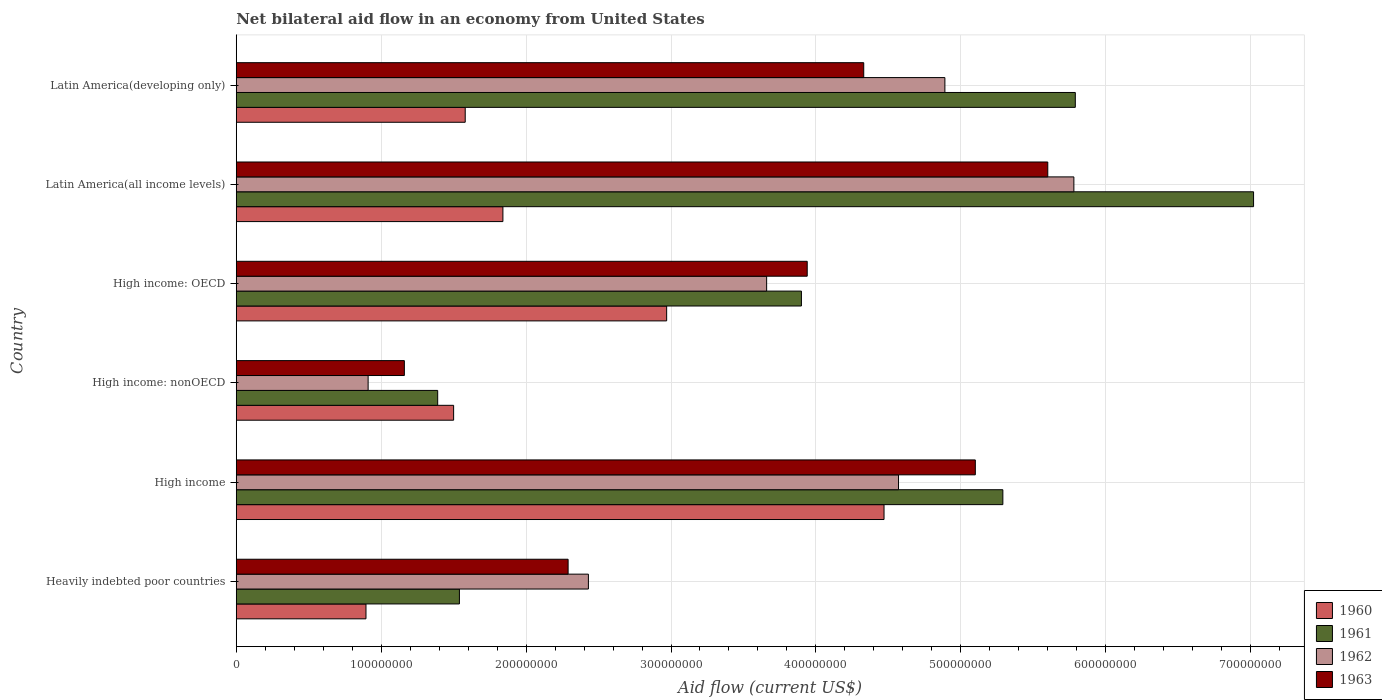How many different coloured bars are there?
Your response must be concise. 4. How many groups of bars are there?
Offer a very short reply. 6. What is the label of the 4th group of bars from the top?
Offer a terse response. High income: nonOECD. In how many cases, is the number of bars for a given country not equal to the number of legend labels?
Ensure brevity in your answer.  0. What is the net bilateral aid flow in 1960 in High income: OECD?
Your answer should be compact. 2.97e+08. Across all countries, what is the maximum net bilateral aid flow in 1962?
Make the answer very short. 5.78e+08. Across all countries, what is the minimum net bilateral aid flow in 1963?
Your response must be concise. 1.16e+08. In which country was the net bilateral aid flow in 1963 maximum?
Provide a succinct answer. Latin America(all income levels). In which country was the net bilateral aid flow in 1961 minimum?
Give a very brief answer. High income: nonOECD. What is the total net bilateral aid flow in 1963 in the graph?
Make the answer very short. 2.24e+09. What is the difference between the net bilateral aid flow in 1962 in Latin America(all income levels) and that in Latin America(developing only)?
Provide a short and direct response. 8.90e+07. What is the difference between the net bilateral aid flow in 1962 in High income and the net bilateral aid flow in 1961 in Latin America(developing only)?
Your answer should be compact. -1.22e+08. What is the average net bilateral aid flow in 1962 per country?
Ensure brevity in your answer.  3.71e+08. What is the difference between the net bilateral aid flow in 1963 and net bilateral aid flow in 1962 in High income: nonOECD?
Give a very brief answer. 2.50e+07. What is the ratio of the net bilateral aid flow in 1960 in Heavily indebted poor countries to that in Latin America(all income levels)?
Ensure brevity in your answer.  0.49. What is the difference between the highest and the second highest net bilateral aid flow in 1963?
Your answer should be compact. 5.00e+07. What is the difference between the highest and the lowest net bilateral aid flow in 1963?
Provide a short and direct response. 4.44e+08. In how many countries, is the net bilateral aid flow in 1961 greater than the average net bilateral aid flow in 1961 taken over all countries?
Your answer should be compact. 3. Is the sum of the net bilateral aid flow in 1961 in Heavily indebted poor countries and High income: OECD greater than the maximum net bilateral aid flow in 1962 across all countries?
Make the answer very short. No. Is it the case that in every country, the sum of the net bilateral aid flow in 1960 and net bilateral aid flow in 1963 is greater than the sum of net bilateral aid flow in 1962 and net bilateral aid flow in 1961?
Your answer should be compact. No. How many bars are there?
Keep it short and to the point. 24. Does the graph contain any zero values?
Your answer should be compact. No. How many legend labels are there?
Your answer should be compact. 4. How are the legend labels stacked?
Make the answer very short. Vertical. What is the title of the graph?
Offer a terse response. Net bilateral aid flow in an economy from United States. What is the label or title of the Y-axis?
Offer a very short reply. Country. What is the Aid flow (current US$) of 1960 in Heavily indebted poor countries?
Make the answer very short. 8.95e+07. What is the Aid flow (current US$) of 1961 in Heavily indebted poor countries?
Make the answer very short. 1.54e+08. What is the Aid flow (current US$) in 1962 in Heavily indebted poor countries?
Offer a terse response. 2.43e+08. What is the Aid flow (current US$) in 1963 in Heavily indebted poor countries?
Your answer should be very brief. 2.29e+08. What is the Aid flow (current US$) of 1960 in High income?
Your answer should be compact. 4.47e+08. What is the Aid flow (current US$) of 1961 in High income?
Your answer should be compact. 5.29e+08. What is the Aid flow (current US$) in 1962 in High income?
Ensure brevity in your answer.  4.57e+08. What is the Aid flow (current US$) of 1963 in High income?
Your response must be concise. 5.10e+08. What is the Aid flow (current US$) of 1960 in High income: nonOECD?
Give a very brief answer. 1.50e+08. What is the Aid flow (current US$) in 1961 in High income: nonOECD?
Your answer should be compact. 1.39e+08. What is the Aid flow (current US$) of 1962 in High income: nonOECD?
Give a very brief answer. 9.10e+07. What is the Aid flow (current US$) of 1963 in High income: nonOECD?
Offer a very short reply. 1.16e+08. What is the Aid flow (current US$) of 1960 in High income: OECD?
Ensure brevity in your answer.  2.97e+08. What is the Aid flow (current US$) of 1961 in High income: OECD?
Ensure brevity in your answer.  3.90e+08. What is the Aid flow (current US$) of 1962 in High income: OECD?
Offer a terse response. 3.66e+08. What is the Aid flow (current US$) in 1963 in High income: OECD?
Make the answer very short. 3.94e+08. What is the Aid flow (current US$) in 1960 in Latin America(all income levels)?
Your answer should be compact. 1.84e+08. What is the Aid flow (current US$) in 1961 in Latin America(all income levels)?
Your answer should be very brief. 7.02e+08. What is the Aid flow (current US$) in 1962 in Latin America(all income levels)?
Make the answer very short. 5.78e+08. What is the Aid flow (current US$) in 1963 in Latin America(all income levels)?
Make the answer very short. 5.60e+08. What is the Aid flow (current US$) in 1960 in Latin America(developing only)?
Provide a short and direct response. 1.58e+08. What is the Aid flow (current US$) of 1961 in Latin America(developing only)?
Keep it short and to the point. 5.79e+08. What is the Aid flow (current US$) of 1962 in Latin America(developing only)?
Make the answer very short. 4.89e+08. What is the Aid flow (current US$) of 1963 in Latin America(developing only)?
Provide a succinct answer. 4.33e+08. Across all countries, what is the maximum Aid flow (current US$) of 1960?
Make the answer very short. 4.47e+08. Across all countries, what is the maximum Aid flow (current US$) of 1961?
Make the answer very short. 7.02e+08. Across all countries, what is the maximum Aid flow (current US$) of 1962?
Your answer should be very brief. 5.78e+08. Across all countries, what is the maximum Aid flow (current US$) of 1963?
Your answer should be very brief. 5.60e+08. Across all countries, what is the minimum Aid flow (current US$) in 1960?
Make the answer very short. 8.95e+07. Across all countries, what is the minimum Aid flow (current US$) of 1961?
Offer a very short reply. 1.39e+08. Across all countries, what is the minimum Aid flow (current US$) in 1962?
Keep it short and to the point. 9.10e+07. Across all countries, what is the minimum Aid flow (current US$) in 1963?
Your answer should be very brief. 1.16e+08. What is the total Aid flow (current US$) in 1960 in the graph?
Provide a succinct answer. 1.33e+09. What is the total Aid flow (current US$) in 1961 in the graph?
Your answer should be compact. 2.49e+09. What is the total Aid flow (current US$) in 1962 in the graph?
Keep it short and to the point. 2.22e+09. What is the total Aid flow (current US$) of 1963 in the graph?
Keep it short and to the point. 2.24e+09. What is the difference between the Aid flow (current US$) of 1960 in Heavily indebted poor countries and that in High income?
Keep it short and to the point. -3.57e+08. What is the difference between the Aid flow (current US$) of 1961 in Heavily indebted poor countries and that in High income?
Offer a terse response. -3.75e+08. What is the difference between the Aid flow (current US$) in 1962 in Heavily indebted poor countries and that in High income?
Keep it short and to the point. -2.14e+08. What is the difference between the Aid flow (current US$) of 1963 in Heavily indebted poor countries and that in High income?
Keep it short and to the point. -2.81e+08. What is the difference between the Aid flow (current US$) of 1960 in Heavily indebted poor countries and that in High income: nonOECD?
Ensure brevity in your answer.  -6.05e+07. What is the difference between the Aid flow (current US$) in 1961 in Heavily indebted poor countries and that in High income: nonOECD?
Offer a terse response. 1.50e+07. What is the difference between the Aid flow (current US$) in 1962 in Heavily indebted poor countries and that in High income: nonOECD?
Offer a terse response. 1.52e+08. What is the difference between the Aid flow (current US$) of 1963 in Heavily indebted poor countries and that in High income: nonOECD?
Offer a terse response. 1.13e+08. What is the difference between the Aid flow (current US$) of 1960 in Heavily indebted poor countries and that in High income: OECD?
Keep it short and to the point. -2.07e+08. What is the difference between the Aid flow (current US$) in 1961 in Heavily indebted poor countries and that in High income: OECD?
Your answer should be very brief. -2.36e+08. What is the difference between the Aid flow (current US$) in 1962 in Heavily indebted poor countries and that in High income: OECD?
Offer a terse response. -1.23e+08. What is the difference between the Aid flow (current US$) of 1963 in Heavily indebted poor countries and that in High income: OECD?
Provide a short and direct response. -1.65e+08. What is the difference between the Aid flow (current US$) in 1960 in Heavily indebted poor countries and that in Latin America(all income levels)?
Give a very brief answer. -9.45e+07. What is the difference between the Aid flow (current US$) of 1961 in Heavily indebted poor countries and that in Latin America(all income levels)?
Your answer should be compact. -5.48e+08. What is the difference between the Aid flow (current US$) of 1962 in Heavily indebted poor countries and that in Latin America(all income levels)?
Your answer should be compact. -3.35e+08. What is the difference between the Aid flow (current US$) in 1963 in Heavily indebted poor countries and that in Latin America(all income levels)?
Make the answer very short. -3.31e+08. What is the difference between the Aid flow (current US$) of 1960 in Heavily indebted poor countries and that in Latin America(developing only)?
Keep it short and to the point. -6.85e+07. What is the difference between the Aid flow (current US$) in 1961 in Heavily indebted poor countries and that in Latin America(developing only)?
Offer a very short reply. -4.25e+08. What is the difference between the Aid flow (current US$) of 1962 in Heavily indebted poor countries and that in Latin America(developing only)?
Your answer should be compact. -2.46e+08. What is the difference between the Aid flow (current US$) of 1963 in Heavily indebted poor countries and that in Latin America(developing only)?
Offer a very short reply. -2.04e+08. What is the difference between the Aid flow (current US$) of 1960 in High income and that in High income: nonOECD?
Make the answer very short. 2.97e+08. What is the difference between the Aid flow (current US$) in 1961 in High income and that in High income: nonOECD?
Ensure brevity in your answer.  3.90e+08. What is the difference between the Aid flow (current US$) in 1962 in High income and that in High income: nonOECD?
Make the answer very short. 3.66e+08. What is the difference between the Aid flow (current US$) in 1963 in High income and that in High income: nonOECD?
Keep it short and to the point. 3.94e+08. What is the difference between the Aid flow (current US$) of 1960 in High income and that in High income: OECD?
Your answer should be very brief. 1.50e+08. What is the difference between the Aid flow (current US$) of 1961 in High income and that in High income: OECD?
Offer a very short reply. 1.39e+08. What is the difference between the Aid flow (current US$) in 1962 in High income and that in High income: OECD?
Offer a terse response. 9.10e+07. What is the difference between the Aid flow (current US$) of 1963 in High income and that in High income: OECD?
Make the answer very short. 1.16e+08. What is the difference between the Aid flow (current US$) of 1960 in High income and that in Latin America(all income levels)?
Offer a terse response. 2.63e+08. What is the difference between the Aid flow (current US$) in 1961 in High income and that in Latin America(all income levels)?
Provide a succinct answer. -1.73e+08. What is the difference between the Aid flow (current US$) of 1962 in High income and that in Latin America(all income levels)?
Offer a terse response. -1.21e+08. What is the difference between the Aid flow (current US$) of 1963 in High income and that in Latin America(all income levels)?
Keep it short and to the point. -5.00e+07. What is the difference between the Aid flow (current US$) in 1960 in High income and that in Latin America(developing only)?
Keep it short and to the point. 2.89e+08. What is the difference between the Aid flow (current US$) in 1961 in High income and that in Latin America(developing only)?
Make the answer very short. -5.00e+07. What is the difference between the Aid flow (current US$) of 1962 in High income and that in Latin America(developing only)?
Offer a very short reply. -3.20e+07. What is the difference between the Aid flow (current US$) of 1963 in High income and that in Latin America(developing only)?
Your answer should be very brief. 7.70e+07. What is the difference between the Aid flow (current US$) of 1960 in High income: nonOECD and that in High income: OECD?
Your answer should be very brief. -1.47e+08. What is the difference between the Aid flow (current US$) of 1961 in High income: nonOECD and that in High income: OECD?
Make the answer very short. -2.51e+08. What is the difference between the Aid flow (current US$) of 1962 in High income: nonOECD and that in High income: OECD?
Your answer should be compact. -2.75e+08. What is the difference between the Aid flow (current US$) in 1963 in High income: nonOECD and that in High income: OECD?
Provide a short and direct response. -2.78e+08. What is the difference between the Aid flow (current US$) of 1960 in High income: nonOECD and that in Latin America(all income levels)?
Keep it short and to the point. -3.40e+07. What is the difference between the Aid flow (current US$) in 1961 in High income: nonOECD and that in Latin America(all income levels)?
Give a very brief answer. -5.63e+08. What is the difference between the Aid flow (current US$) of 1962 in High income: nonOECD and that in Latin America(all income levels)?
Ensure brevity in your answer.  -4.87e+08. What is the difference between the Aid flow (current US$) in 1963 in High income: nonOECD and that in Latin America(all income levels)?
Your answer should be compact. -4.44e+08. What is the difference between the Aid flow (current US$) of 1960 in High income: nonOECD and that in Latin America(developing only)?
Keep it short and to the point. -8.00e+06. What is the difference between the Aid flow (current US$) of 1961 in High income: nonOECD and that in Latin America(developing only)?
Provide a succinct answer. -4.40e+08. What is the difference between the Aid flow (current US$) of 1962 in High income: nonOECD and that in Latin America(developing only)?
Your response must be concise. -3.98e+08. What is the difference between the Aid flow (current US$) in 1963 in High income: nonOECD and that in Latin America(developing only)?
Give a very brief answer. -3.17e+08. What is the difference between the Aid flow (current US$) of 1960 in High income: OECD and that in Latin America(all income levels)?
Offer a terse response. 1.13e+08. What is the difference between the Aid flow (current US$) in 1961 in High income: OECD and that in Latin America(all income levels)?
Ensure brevity in your answer.  -3.12e+08. What is the difference between the Aid flow (current US$) in 1962 in High income: OECD and that in Latin America(all income levels)?
Offer a terse response. -2.12e+08. What is the difference between the Aid flow (current US$) of 1963 in High income: OECD and that in Latin America(all income levels)?
Ensure brevity in your answer.  -1.66e+08. What is the difference between the Aid flow (current US$) of 1960 in High income: OECD and that in Latin America(developing only)?
Your response must be concise. 1.39e+08. What is the difference between the Aid flow (current US$) of 1961 in High income: OECD and that in Latin America(developing only)?
Your response must be concise. -1.89e+08. What is the difference between the Aid flow (current US$) of 1962 in High income: OECD and that in Latin America(developing only)?
Provide a succinct answer. -1.23e+08. What is the difference between the Aid flow (current US$) of 1963 in High income: OECD and that in Latin America(developing only)?
Provide a succinct answer. -3.90e+07. What is the difference between the Aid flow (current US$) in 1960 in Latin America(all income levels) and that in Latin America(developing only)?
Your answer should be compact. 2.60e+07. What is the difference between the Aid flow (current US$) in 1961 in Latin America(all income levels) and that in Latin America(developing only)?
Provide a short and direct response. 1.23e+08. What is the difference between the Aid flow (current US$) in 1962 in Latin America(all income levels) and that in Latin America(developing only)?
Ensure brevity in your answer.  8.90e+07. What is the difference between the Aid flow (current US$) in 1963 in Latin America(all income levels) and that in Latin America(developing only)?
Your response must be concise. 1.27e+08. What is the difference between the Aid flow (current US$) in 1960 in Heavily indebted poor countries and the Aid flow (current US$) in 1961 in High income?
Offer a very short reply. -4.39e+08. What is the difference between the Aid flow (current US$) of 1960 in Heavily indebted poor countries and the Aid flow (current US$) of 1962 in High income?
Your answer should be very brief. -3.67e+08. What is the difference between the Aid flow (current US$) of 1960 in Heavily indebted poor countries and the Aid flow (current US$) of 1963 in High income?
Offer a terse response. -4.20e+08. What is the difference between the Aid flow (current US$) in 1961 in Heavily indebted poor countries and the Aid flow (current US$) in 1962 in High income?
Your response must be concise. -3.03e+08. What is the difference between the Aid flow (current US$) of 1961 in Heavily indebted poor countries and the Aid flow (current US$) of 1963 in High income?
Offer a terse response. -3.56e+08. What is the difference between the Aid flow (current US$) in 1962 in Heavily indebted poor countries and the Aid flow (current US$) in 1963 in High income?
Your answer should be compact. -2.67e+08. What is the difference between the Aid flow (current US$) of 1960 in Heavily indebted poor countries and the Aid flow (current US$) of 1961 in High income: nonOECD?
Keep it short and to the point. -4.95e+07. What is the difference between the Aid flow (current US$) of 1960 in Heavily indebted poor countries and the Aid flow (current US$) of 1962 in High income: nonOECD?
Offer a terse response. -1.48e+06. What is the difference between the Aid flow (current US$) of 1960 in Heavily indebted poor countries and the Aid flow (current US$) of 1963 in High income: nonOECD?
Provide a succinct answer. -2.65e+07. What is the difference between the Aid flow (current US$) in 1961 in Heavily indebted poor countries and the Aid flow (current US$) in 1962 in High income: nonOECD?
Give a very brief answer. 6.30e+07. What is the difference between the Aid flow (current US$) of 1961 in Heavily indebted poor countries and the Aid flow (current US$) of 1963 in High income: nonOECD?
Ensure brevity in your answer.  3.80e+07. What is the difference between the Aid flow (current US$) of 1962 in Heavily indebted poor countries and the Aid flow (current US$) of 1963 in High income: nonOECD?
Offer a very short reply. 1.27e+08. What is the difference between the Aid flow (current US$) in 1960 in Heavily indebted poor countries and the Aid flow (current US$) in 1961 in High income: OECD?
Provide a succinct answer. -3.00e+08. What is the difference between the Aid flow (current US$) in 1960 in Heavily indebted poor countries and the Aid flow (current US$) in 1962 in High income: OECD?
Make the answer very short. -2.76e+08. What is the difference between the Aid flow (current US$) of 1960 in Heavily indebted poor countries and the Aid flow (current US$) of 1963 in High income: OECD?
Your response must be concise. -3.04e+08. What is the difference between the Aid flow (current US$) in 1961 in Heavily indebted poor countries and the Aid flow (current US$) in 1962 in High income: OECD?
Offer a terse response. -2.12e+08. What is the difference between the Aid flow (current US$) in 1961 in Heavily indebted poor countries and the Aid flow (current US$) in 1963 in High income: OECD?
Your answer should be compact. -2.40e+08. What is the difference between the Aid flow (current US$) of 1962 in Heavily indebted poor countries and the Aid flow (current US$) of 1963 in High income: OECD?
Give a very brief answer. -1.51e+08. What is the difference between the Aid flow (current US$) in 1960 in Heavily indebted poor countries and the Aid flow (current US$) in 1961 in Latin America(all income levels)?
Provide a short and direct response. -6.12e+08. What is the difference between the Aid flow (current US$) in 1960 in Heavily indebted poor countries and the Aid flow (current US$) in 1962 in Latin America(all income levels)?
Offer a very short reply. -4.88e+08. What is the difference between the Aid flow (current US$) of 1960 in Heavily indebted poor countries and the Aid flow (current US$) of 1963 in Latin America(all income levels)?
Your response must be concise. -4.70e+08. What is the difference between the Aid flow (current US$) in 1961 in Heavily indebted poor countries and the Aid flow (current US$) in 1962 in Latin America(all income levels)?
Offer a terse response. -4.24e+08. What is the difference between the Aid flow (current US$) of 1961 in Heavily indebted poor countries and the Aid flow (current US$) of 1963 in Latin America(all income levels)?
Provide a short and direct response. -4.06e+08. What is the difference between the Aid flow (current US$) of 1962 in Heavily indebted poor countries and the Aid flow (current US$) of 1963 in Latin America(all income levels)?
Make the answer very short. -3.17e+08. What is the difference between the Aid flow (current US$) in 1960 in Heavily indebted poor countries and the Aid flow (current US$) in 1961 in Latin America(developing only)?
Your answer should be very brief. -4.89e+08. What is the difference between the Aid flow (current US$) of 1960 in Heavily indebted poor countries and the Aid flow (current US$) of 1962 in Latin America(developing only)?
Your response must be concise. -3.99e+08. What is the difference between the Aid flow (current US$) in 1960 in Heavily indebted poor countries and the Aid flow (current US$) in 1963 in Latin America(developing only)?
Provide a short and direct response. -3.43e+08. What is the difference between the Aid flow (current US$) of 1961 in Heavily indebted poor countries and the Aid flow (current US$) of 1962 in Latin America(developing only)?
Provide a short and direct response. -3.35e+08. What is the difference between the Aid flow (current US$) in 1961 in Heavily indebted poor countries and the Aid flow (current US$) in 1963 in Latin America(developing only)?
Give a very brief answer. -2.79e+08. What is the difference between the Aid flow (current US$) in 1962 in Heavily indebted poor countries and the Aid flow (current US$) in 1963 in Latin America(developing only)?
Provide a succinct answer. -1.90e+08. What is the difference between the Aid flow (current US$) in 1960 in High income and the Aid flow (current US$) in 1961 in High income: nonOECD?
Provide a short and direct response. 3.08e+08. What is the difference between the Aid flow (current US$) of 1960 in High income and the Aid flow (current US$) of 1962 in High income: nonOECD?
Ensure brevity in your answer.  3.56e+08. What is the difference between the Aid flow (current US$) of 1960 in High income and the Aid flow (current US$) of 1963 in High income: nonOECD?
Your answer should be very brief. 3.31e+08. What is the difference between the Aid flow (current US$) in 1961 in High income and the Aid flow (current US$) in 1962 in High income: nonOECD?
Make the answer very short. 4.38e+08. What is the difference between the Aid flow (current US$) in 1961 in High income and the Aid flow (current US$) in 1963 in High income: nonOECD?
Your answer should be compact. 4.13e+08. What is the difference between the Aid flow (current US$) of 1962 in High income and the Aid flow (current US$) of 1963 in High income: nonOECD?
Provide a short and direct response. 3.41e+08. What is the difference between the Aid flow (current US$) in 1960 in High income and the Aid flow (current US$) in 1961 in High income: OECD?
Offer a terse response. 5.70e+07. What is the difference between the Aid flow (current US$) in 1960 in High income and the Aid flow (current US$) in 1962 in High income: OECD?
Offer a very short reply. 8.10e+07. What is the difference between the Aid flow (current US$) of 1960 in High income and the Aid flow (current US$) of 1963 in High income: OECD?
Make the answer very short. 5.30e+07. What is the difference between the Aid flow (current US$) of 1961 in High income and the Aid flow (current US$) of 1962 in High income: OECD?
Your answer should be compact. 1.63e+08. What is the difference between the Aid flow (current US$) of 1961 in High income and the Aid flow (current US$) of 1963 in High income: OECD?
Ensure brevity in your answer.  1.35e+08. What is the difference between the Aid flow (current US$) in 1962 in High income and the Aid flow (current US$) in 1963 in High income: OECD?
Give a very brief answer. 6.30e+07. What is the difference between the Aid flow (current US$) in 1960 in High income and the Aid flow (current US$) in 1961 in Latin America(all income levels)?
Your answer should be very brief. -2.55e+08. What is the difference between the Aid flow (current US$) of 1960 in High income and the Aid flow (current US$) of 1962 in Latin America(all income levels)?
Offer a terse response. -1.31e+08. What is the difference between the Aid flow (current US$) of 1960 in High income and the Aid flow (current US$) of 1963 in Latin America(all income levels)?
Make the answer very short. -1.13e+08. What is the difference between the Aid flow (current US$) in 1961 in High income and the Aid flow (current US$) in 1962 in Latin America(all income levels)?
Your response must be concise. -4.90e+07. What is the difference between the Aid flow (current US$) in 1961 in High income and the Aid flow (current US$) in 1963 in Latin America(all income levels)?
Your response must be concise. -3.10e+07. What is the difference between the Aid flow (current US$) of 1962 in High income and the Aid flow (current US$) of 1963 in Latin America(all income levels)?
Give a very brief answer. -1.03e+08. What is the difference between the Aid flow (current US$) of 1960 in High income and the Aid flow (current US$) of 1961 in Latin America(developing only)?
Offer a terse response. -1.32e+08. What is the difference between the Aid flow (current US$) in 1960 in High income and the Aid flow (current US$) in 1962 in Latin America(developing only)?
Offer a terse response. -4.20e+07. What is the difference between the Aid flow (current US$) in 1960 in High income and the Aid flow (current US$) in 1963 in Latin America(developing only)?
Ensure brevity in your answer.  1.40e+07. What is the difference between the Aid flow (current US$) of 1961 in High income and the Aid flow (current US$) of 1962 in Latin America(developing only)?
Your answer should be very brief. 4.00e+07. What is the difference between the Aid flow (current US$) of 1961 in High income and the Aid flow (current US$) of 1963 in Latin America(developing only)?
Offer a terse response. 9.60e+07. What is the difference between the Aid flow (current US$) in 1962 in High income and the Aid flow (current US$) in 1963 in Latin America(developing only)?
Provide a succinct answer. 2.40e+07. What is the difference between the Aid flow (current US$) in 1960 in High income: nonOECD and the Aid flow (current US$) in 1961 in High income: OECD?
Provide a succinct answer. -2.40e+08. What is the difference between the Aid flow (current US$) of 1960 in High income: nonOECD and the Aid flow (current US$) of 1962 in High income: OECD?
Offer a very short reply. -2.16e+08. What is the difference between the Aid flow (current US$) of 1960 in High income: nonOECD and the Aid flow (current US$) of 1963 in High income: OECD?
Your answer should be compact. -2.44e+08. What is the difference between the Aid flow (current US$) of 1961 in High income: nonOECD and the Aid flow (current US$) of 1962 in High income: OECD?
Your answer should be very brief. -2.27e+08. What is the difference between the Aid flow (current US$) of 1961 in High income: nonOECD and the Aid flow (current US$) of 1963 in High income: OECD?
Offer a very short reply. -2.55e+08. What is the difference between the Aid flow (current US$) in 1962 in High income: nonOECD and the Aid flow (current US$) in 1963 in High income: OECD?
Offer a very short reply. -3.03e+08. What is the difference between the Aid flow (current US$) in 1960 in High income: nonOECD and the Aid flow (current US$) in 1961 in Latin America(all income levels)?
Your response must be concise. -5.52e+08. What is the difference between the Aid flow (current US$) of 1960 in High income: nonOECD and the Aid flow (current US$) of 1962 in Latin America(all income levels)?
Ensure brevity in your answer.  -4.28e+08. What is the difference between the Aid flow (current US$) of 1960 in High income: nonOECD and the Aid flow (current US$) of 1963 in Latin America(all income levels)?
Ensure brevity in your answer.  -4.10e+08. What is the difference between the Aid flow (current US$) of 1961 in High income: nonOECD and the Aid flow (current US$) of 1962 in Latin America(all income levels)?
Make the answer very short. -4.39e+08. What is the difference between the Aid flow (current US$) of 1961 in High income: nonOECD and the Aid flow (current US$) of 1963 in Latin America(all income levels)?
Keep it short and to the point. -4.21e+08. What is the difference between the Aid flow (current US$) in 1962 in High income: nonOECD and the Aid flow (current US$) in 1963 in Latin America(all income levels)?
Offer a very short reply. -4.69e+08. What is the difference between the Aid flow (current US$) of 1960 in High income: nonOECD and the Aid flow (current US$) of 1961 in Latin America(developing only)?
Provide a succinct answer. -4.29e+08. What is the difference between the Aid flow (current US$) of 1960 in High income: nonOECD and the Aid flow (current US$) of 1962 in Latin America(developing only)?
Offer a very short reply. -3.39e+08. What is the difference between the Aid flow (current US$) in 1960 in High income: nonOECD and the Aid flow (current US$) in 1963 in Latin America(developing only)?
Provide a succinct answer. -2.83e+08. What is the difference between the Aid flow (current US$) in 1961 in High income: nonOECD and the Aid flow (current US$) in 1962 in Latin America(developing only)?
Provide a succinct answer. -3.50e+08. What is the difference between the Aid flow (current US$) in 1961 in High income: nonOECD and the Aid flow (current US$) in 1963 in Latin America(developing only)?
Keep it short and to the point. -2.94e+08. What is the difference between the Aid flow (current US$) of 1962 in High income: nonOECD and the Aid flow (current US$) of 1963 in Latin America(developing only)?
Your answer should be very brief. -3.42e+08. What is the difference between the Aid flow (current US$) of 1960 in High income: OECD and the Aid flow (current US$) of 1961 in Latin America(all income levels)?
Ensure brevity in your answer.  -4.05e+08. What is the difference between the Aid flow (current US$) of 1960 in High income: OECD and the Aid flow (current US$) of 1962 in Latin America(all income levels)?
Provide a succinct answer. -2.81e+08. What is the difference between the Aid flow (current US$) in 1960 in High income: OECD and the Aid flow (current US$) in 1963 in Latin America(all income levels)?
Provide a succinct answer. -2.63e+08. What is the difference between the Aid flow (current US$) of 1961 in High income: OECD and the Aid flow (current US$) of 1962 in Latin America(all income levels)?
Keep it short and to the point. -1.88e+08. What is the difference between the Aid flow (current US$) of 1961 in High income: OECD and the Aid flow (current US$) of 1963 in Latin America(all income levels)?
Your response must be concise. -1.70e+08. What is the difference between the Aid flow (current US$) of 1962 in High income: OECD and the Aid flow (current US$) of 1963 in Latin America(all income levels)?
Offer a terse response. -1.94e+08. What is the difference between the Aid flow (current US$) of 1960 in High income: OECD and the Aid flow (current US$) of 1961 in Latin America(developing only)?
Your answer should be compact. -2.82e+08. What is the difference between the Aid flow (current US$) of 1960 in High income: OECD and the Aid flow (current US$) of 1962 in Latin America(developing only)?
Offer a very short reply. -1.92e+08. What is the difference between the Aid flow (current US$) in 1960 in High income: OECD and the Aid flow (current US$) in 1963 in Latin America(developing only)?
Offer a very short reply. -1.36e+08. What is the difference between the Aid flow (current US$) of 1961 in High income: OECD and the Aid flow (current US$) of 1962 in Latin America(developing only)?
Make the answer very short. -9.90e+07. What is the difference between the Aid flow (current US$) in 1961 in High income: OECD and the Aid flow (current US$) in 1963 in Latin America(developing only)?
Your answer should be very brief. -4.30e+07. What is the difference between the Aid flow (current US$) of 1962 in High income: OECD and the Aid flow (current US$) of 1963 in Latin America(developing only)?
Make the answer very short. -6.70e+07. What is the difference between the Aid flow (current US$) in 1960 in Latin America(all income levels) and the Aid flow (current US$) in 1961 in Latin America(developing only)?
Provide a succinct answer. -3.95e+08. What is the difference between the Aid flow (current US$) in 1960 in Latin America(all income levels) and the Aid flow (current US$) in 1962 in Latin America(developing only)?
Your response must be concise. -3.05e+08. What is the difference between the Aid flow (current US$) in 1960 in Latin America(all income levels) and the Aid flow (current US$) in 1963 in Latin America(developing only)?
Your answer should be very brief. -2.49e+08. What is the difference between the Aid flow (current US$) of 1961 in Latin America(all income levels) and the Aid flow (current US$) of 1962 in Latin America(developing only)?
Ensure brevity in your answer.  2.13e+08. What is the difference between the Aid flow (current US$) of 1961 in Latin America(all income levels) and the Aid flow (current US$) of 1963 in Latin America(developing only)?
Provide a succinct answer. 2.69e+08. What is the difference between the Aid flow (current US$) in 1962 in Latin America(all income levels) and the Aid flow (current US$) in 1963 in Latin America(developing only)?
Your answer should be very brief. 1.45e+08. What is the average Aid flow (current US$) of 1960 per country?
Your response must be concise. 2.21e+08. What is the average Aid flow (current US$) of 1961 per country?
Your response must be concise. 4.16e+08. What is the average Aid flow (current US$) of 1962 per country?
Make the answer very short. 3.71e+08. What is the average Aid flow (current US$) of 1963 per country?
Offer a very short reply. 3.74e+08. What is the difference between the Aid flow (current US$) of 1960 and Aid flow (current US$) of 1961 in Heavily indebted poor countries?
Ensure brevity in your answer.  -6.45e+07. What is the difference between the Aid flow (current US$) of 1960 and Aid flow (current US$) of 1962 in Heavily indebted poor countries?
Provide a short and direct response. -1.53e+08. What is the difference between the Aid flow (current US$) of 1960 and Aid flow (current US$) of 1963 in Heavily indebted poor countries?
Offer a very short reply. -1.39e+08. What is the difference between the Aid flow (current US$) in 1961 and Aid flow (current US$) in 1962 in Heavily indebted poor countries?
Ensure brevity in your answer.  -8.90e+07. What is the difference between the Aid flow (current US$) in 1961 and Aid flow (current US$) in 1963 in Heavily indebted poor countries?
Your response must be concise. -7.50e+07. What is the difference between the Aid flow (current US$) of 1962 and Aid flow (current US$) of 1963 in Heavily indebted poor countries?
Provide a short and direct response. 1.40e+07. What is the difference between the Aid flow (current US$) in 1960 and Aid flow (current US$) in 1961 in High income?
Your answer should be very brief. -8.20e+07. What is the difference between the Aid flow (current US$) of 1960 and Aid flow (current US$) of 1962 in High income?
Ensure brevity in your answer.  -1.00e+07. What is the difference between the Aid flow (current US$) of 1960 and Aid flow (current US$) of 1963 in High income?
Keep it short and to the point. -6.30e+07. What is the difference between the Aid flow (current US$) in 1961 and Aid flow (current US$) in 1962 in High income?
Your answer should be very brief. 7.20e+07. What is the difference between the Aid flow (current US$) of 1961 and Aid flow (current US$) of 1963 in High income?
Ensure brevity in your answer.  1.90e+07. What is the difference between the Aid flow (current US$) in 1962 and Aid flow (current US$) in 1963 in High income?
Give a very brief answer. -5.30e+07. What is the difference between the Aid flow (current US$) of 1960 and Aid flow (current US$) of 1961 in High income: nonOECD?
Offer a terse response. 1.10e+07. What is the difference between the Aid flow (current US$) of 1960 and Aid flow (current US$) of 1962 in High income: nonOECD?
Provide a short and direct response. 5.90e+07. What is the difference between the Aid flow (current US$) of 1960 and Aid flow (current US$) of 1963 in High income: nonOECD?
Offer a very short reply. 3.40e+07. What is the difference between the Aid flow (current US$) of 1961 and Aid flow (current US$) of 1962 in High income: nonOECD?
Offer a very short reply. 4.80e+07. What is the difference between the Aid flow (current US$) in 1961 and Aid flow (current US$) in 1963 in High income: nonOECD?
Your answer should be compact. 2.30e+07. What is the difference between the Aid flow (current US$) of 1962 and Aid flow (current US$) of 1963 in High income: nonOECD?
Your answer should be compact. -2.50e+07. What is the difference between the Aid flow (current US$) of 1960 and Aid flow (current US$) of 1961 in High income: OECD?
Provide a succinct answer. -9.30e+07. What is the difference between the Aid flow (current US$) of 1960 and Aid flow (current US$) of 1962 in High income: OECD?
Keep it short and to the point. -6.90e+07. What is the difference between the Aid flow (current US$) of 1960 and Aid flow (current US$) of 1963 in High income: OECD?
Ensure brevity in your answer.  -9.70e+07. What is the difference between the Aid flow (current US$) in 1961 and Aid flow (current US$) in 1962 in High income: OECD?
Provide a succinct answer. 2.40e+07. What is the difference between the Aid flow (current US$) in 1961 and Aid flow (current US$) in 1963 in High income: OECD?
Keep it short and to the point. -4.00e+06. What is the difference between the Aid flow (current US$) of 1962 and Aid flow (current US$) of 1963 in High income: OECD?
Offer a terse response. -2.80e+07. What is the difference between the Aid flow (current US$) in 1960 and Aid flow (current US$) in 1961 in Latin America(all income levels)?
Provide a succinct answer. -5.18e+08. What is the difference between the Aid flow (current US$) of 1960 and Aid flow (current US$) of 1962 in Latin America(all income levels)?
Ensure brevity in your answer.  -3.94e+08. What is the difference between the Aid flow (current US$) of 1960 and Aid flow (current US$) of 1963 in Latin America(all income levels)?
Keep it short and to the point. -3.76e+08. What is the difference between the Aid flow (current US$) in 1961 and Aid flow (current US$) in 1962 in Latin America(all income levels)?
Ensure brevity in your answer.  1.24e+08. What is the difference between the Aid flow (current US$) of 1961 and Aid flow (current US$) of 1963 in Latin America(all income levels)?
Ensure brevity in your answer.  1.42e+08. What is the difference between the Aid flow (current US$) in 1962 and Aid flow (current US$) in 1963 in Latin America(all income levels)?
Offer a very short reply. 1.80e+07. What is the difference between the Aid flow (current US$) in 1960 and Aid flow (current US$) in 1961 in Latin America(developing only)?
Keep it short and to the point. -4.21e+08. What is the difference between the Aid flow (current US$) in 1960 and Aid flow (current US$) in 1962 in Latin America(developing only)?
Your answer should be compact. -3.31e+08. What is the difference between the Aid flow (current US$) in 1960 and Aid flow (current US$) in 1963 in Latin America(developing only)?
Your answer should be very brief. -2.75e+08. What is the difference between the Aid flow (current US$) of 1961 and Aid flow (current US$) of 1962 in Latin America(developing only)?
Give a very brief answer. 9.00e+07. What is the difference between the Aid flow (current US$) in 1961 and Aid flow (current US$) in 1963 in Latin America(developing only)?
Keep it short and to the point. 1.46e+08. What is the difference between the Aid flow (current US$) in 1962 and Aid flow (current US$) in 1963 in Latin America(developing only)?
Ensure brevity in your answer.  5.60e+07. What is the ratio of the Aid flow (current US$) in 1960 in Heavily indebted poor countries to that in High income?
Make the answer very short. 0.2. What is the ratio of the Aid flow (current US$) of 1961 in Heavily indebted poor countries to that in High income?
Ensure brevity in your answer.  0.29. What is the ratio of the Aid flow (current US$) in 1962 in Heavily indebted poor countries to that in High income?
Your answer should be very brief. 0.53. What is the ratio of the Aid flow (current US$) in 1963 in Heavily indebted poor countries to that in High income?
Keep it short and to the point. 0.45. What is the ratio of the Aid flow (current US$) of 1960 in Heavily indebted poor countries to that in High income: nonOECD?
Keep it short and to the point. 0.6. What is the ratio of the Aid flow (current US$) of 1961 in Heavily indebted poor countries to that in High income: nonOECD?
Ensure brevity in your answer.  1.11. What is the ratio of the Aid flow (current US$) of 1962 in Heavily indebted poor countries to that in High income: nonOECD?
Offer a terse response. 2.67. What is the ratio of the Aid flow (current US$) in 1963 in Heavily indebted poor countries to that in High income: nonOECD?
Keep it short and to the point. 1.97. What is the ratio of the Aid flow (current US$) of 1960 in Heavily indebted poor countries to that in High income: OECD?
Your answer should be compact. 0.3. What is the ratio of the Aid flow (current US$) in 1961 in Heavily indebted poor countries to that in High income: OECD?
Offer a very short reply. 0.39. What is the ratio of the Aid flow (current US$) of 1962 in Heavily indebted poor countries to that in High income: OECD?
Offer a terse response. 0.66. What is the ratio of the Aid flow (current US$) of 1963 in Heavily indebted poor countries to that in High income: OECD?
Your response must be concise. 0.58. What is the ratio of the Aid flow (current US$) of 1960 in Heavily indebted poor countries to that in Latin America(all income levels)?
Offer a terse response. 0.49. What is the ratio of the Aid flow (current US$) in 1961 in Heavily indebted poor countries to that in Latin America(all income levels)?
Your response must be concise. 0.22. What is the ratio of the Aid flow (current US$) in 1962 in Heavily indebted poor countries to that in Latin America(all income levels)?
Your answer should be compact. 0.42. What is the ratio of the Aid flow (current US$) of 1963 in Heavily indebted poor countries to that in Latin America(all income levels)?
Ensure brevity in your answer.  0.41. What is the ratio of the Aid flow (current US$) of 1960 in Heavily indebted poor countries to that in Latin America(developing only)?
Ensure brevity in your answer.  0.57. What is the ratio of the Aid flow (current US$) of 1961 in Heavily indebted poor countries to that in Latin America(developing only)?
Provide a succinct answer. 0.27. What is the ratio of the Aid flow (current US$) in 1962 in Heavily indebted poor countries to that in Latin America(developing only)?
Offer a terse response. 0.5. What is the ratio of the Aid flow (current US$) in 1963 in Heavily indebted poor countries to that in Latin America(developing only)?
Your answer should be compact. 0.53. What is the ratio of the Aid flow (current US$) of 1960 in High income to that in High income: nonOECD?
Offer a terse response. 2.98. What is the ratio of the Aid flow (current US$) in 1961 in High income to that in High income: nonOECD?
Your answer should be compact. 3.81. What is the ratio of the Aid flow (current US$) of 1962 in High income to that in High income: nonOECD?
Your answer should be compact. 5.02. What is the ratio of the Aid flow (current US$) in 1963 in High income to that in High income: nonOECD?
Give a very brief answer. 4.4. What is the ratio of the Aid flow (current US$) of 1960 in High income to that in High income: OECD?
Your answer should be very brief. 1.51. What is the ratio of the Aid flow (current US$) of 1961 in High income to that in High income: OECD?
Make the answer very short. 1.36. What is the ratio of the Aid flow (current US$) of 1962 in High income to that in High income: OECD?
Give a very brief answer. 1.25. What is the ratio of the Aid flow (current US$) of 1963 in High income to that in High income: OECD?
Offer a very short reply. 1.29. What is the ratio of the Aid flow (current US$) in 1960 in High income to that in Latin America(all income levels)?
Your answer should be compact. 2.43. What is the ratio of the Aid flow (current US$) in 1961 in High income to that in Latin America(all income levels)?
Keep it short and to the point. 0.75. What is the ratio of the Aid flow (current US$) of 1962 in High income to that in Latin America(all income levels)?
Your response must be concise. 0.79. What is the ratio of the Aid flow (current US$) of 1963 in High income to that in Latin America(all income levels)?
Offer a very short reply. 0.91. What is the ratio of the Aid flow (current US$) of 1960 in High income to that in Latin America(developing only)?
Provide a short and direct response. 2.83. What is the ratio of the Aid flow (current US$) of 1961 in High income to that in Latin America(developing only)?
Your answer should be very brief. 0.91. What is the ratio of the Aid flow (current US$) of 1962 in High income to that in Latin America(developing only)?
Provide a succinct answer. 0.93. What is the ratio of the Aid flow (current US$) in 1963 in High income to that in Latin America(developing only)?
Your response must be concise. 1.18. What is the ratio of the Aid flow (current US$) of 1960 in High income: nonOECD to that in High income: OECD?
Ensure brevity in your answer.  0.51. What is the ratio of the Aid flow (current US$) of 1961 in High income: nonOECD to that in High income: OECD?
Your response must be concise. 0.36. What is the ratio of the Aid flow (current US$) of 1962 in High income: nonOECD to that in High income: OECD?
Offer a very short reply. 0.25. What is the ratio of the Aid flow (current US$) of 1963 in High income: nonOECD to that in High income: OECD?
Provide a short and direct response. 0.29. What is the ratio of the Aid flow (current US$) in 1960 in High income: nonOECD to that in Latin America(all income levels)?
Ensure brevity in your answer.  0.82. What is the ratio of the Aid flow (current US$) of 1961 in High income: nonOECD to that in Latin America(all income levels)?
Keep it short and to the point. 0.2. What is the ratio of the Aid flow (current US$) in 1962 in High income: nonOECD to that in Latin America(all income levels)?
Keep it short and to the point. 0.16. What is the ratio of the Aid flow (current US$) in 1963 in High income: nonOECD to that in Latin America(all income levels)?
Give a very brief answer. 0.21. What is the ratio of the Aid flow (current US$) in 1960 in High income: nonOECD to that in Latin America(developing only)?
Give a very brief answer. 0.95. What is the ratio of the Aid flow (current US$) in 1961 in High income: nonOECD to that in Latin America(developing only)?
Make the answer very short. 0.24. What is the ratio of the Aid flow (current US$) in 1962 in High income: nonOECD to that in Latin America(developing only)?
Offer a very short reply. 0.19. What is the ratio of the Aid flow (current US$) of 1963 in High income: nonOECD to that in Latin America(developing only)?
Provide a succinct answer. 0.27. What is the ratio of the Aid flow (current US$) in 1960 in High income: OECD to that in Latin America(all income levels)?
Provide a succinct answer. 1.61. What is the ratio of the Aid flow (current US$) in 1961 in High income: OECD to that in Latin America(all income levels)?
Provide a short and direct response. 0.56. What is the ratio of the Aid flow (current US$) of 1962 in High income: OECD to that in Latin America(all income levels)?
Ensure brevity in your answer.  0.63. What is the ratio of the Aid flow (current US$) in 1963 in High income: OECD to that in Latin America(all income levels)?
Provide a succinct answer. 0.7. What is the ratio of the Aid flow (current US$) in 1960 in High income: OECD to that in Latin America(developing only)?
Your response must be concise. 1.88. What is the ratio of the Aid flow (current US$) in 1961 in High income: OECD to that in Latin America(developing only)?
Keep it short and to the point. 0.67. What is the ratio of the Aid flow (current US$) of 1962 in High income: OECD to that in Latin America(developing only)?
Ensure brevity in your answer.  0.75. What is the ratio of the Aid flow (current US$) in 1963 in High income: OECD to that in Latin America(developing only)?
Provide a short and direct response. 0.91. What is the ratio of the Aid flow (current US$) in 1960 in Latin America(all income levels) to that in Latin America(developing only)?
Give a very brief answer. 1.16. What is the ratio of the Aid flow (current US$) in 1961 in Latin America(all income levels) to that in Latin America(developing only)?
Your answer should be very brief. 1.21. What is the ratio of the Aid flow (current US$) in 1962 in Latin America(all income levels) to that in Latin America(developing only)?
Offer a very short reply. 1.18. What is the ratio of the Aid flow (current US$) of 1963 in Latin America(all income levels) to that in Latin America(developing only)?
Provide a short and direct response. 1.29. What is the difference between the highest and the second highest Aid flow (current US$) in 1960?
Your response must be concise. 1.50e+08. What is the difference between the highest and the second highest Aid flow (current US$) of 1961?
Offer a terse response. 1.23e+08. What is the difference between the highest and the second highest Aid flow (current US$) of 1962?
Ensure brevity in your answer.  8.90e+07. What is the difference between the highest and the second highest Aid flow (current US$) in 1963?
Provide a short and direct response. 5.00e+07. What is the difference between the highest and the lowest Aid flow (current US$) in 1960?
Make the answer very short. 3.57e+08. What is the difference between the highest and the lowest Aid flow (current US$) of 1961?
Offer a terse response. 5.63e+08. What is the difference between the highest and the lowest Aid flow (current US$) of 1962?
Provide a short and direct response. 4.87e+08. What is the difference between the highest and the lowest Aid flow (current US$) of 1963?
Offer a very short reply. 4.44e+08. 